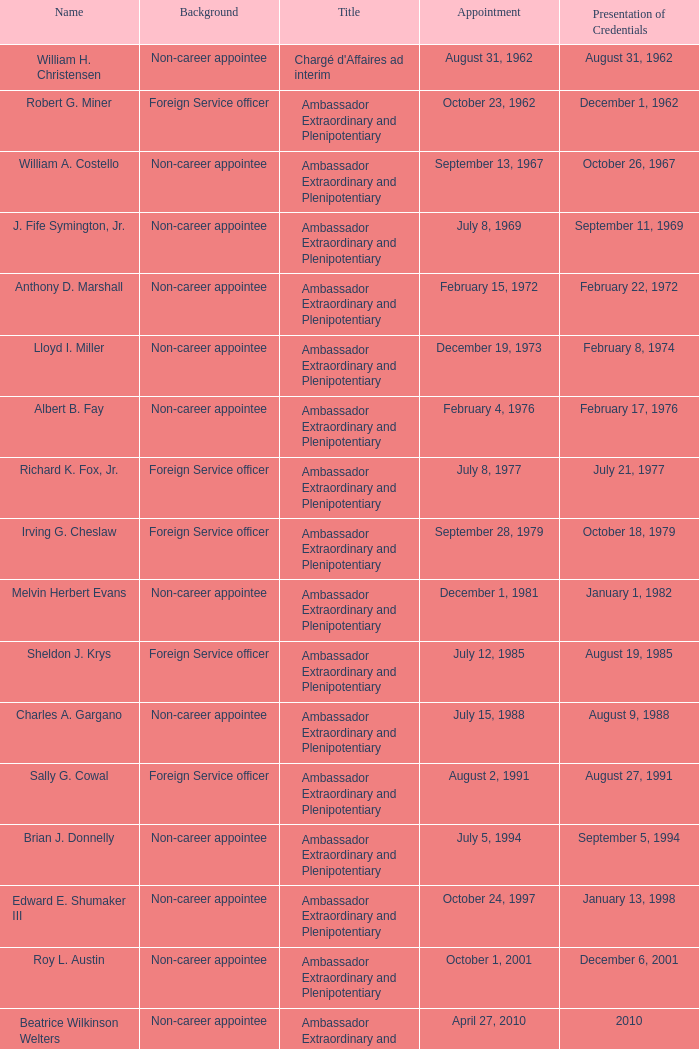When was william a. costello assigned? September 13, 1967. 